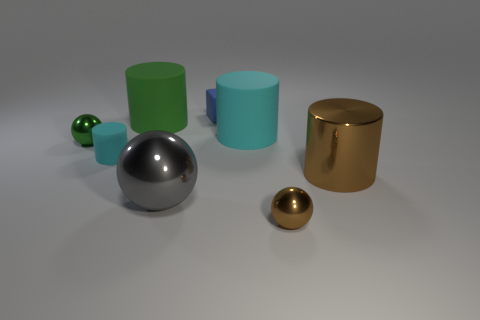Subtract all blocks. How many objects are left? 7 Subtract all big green metallic cylinders. Subtract all brown metallic balls. How many objects are left? 7 Add 1 big cyan rubber cylinders. How many big cyan rubber cylinders are left? 2 Add 4 metallic cylinders. How many metallic cylinders exist? 5 Subtract 0 yellow spheres. How many objects are left? 8 